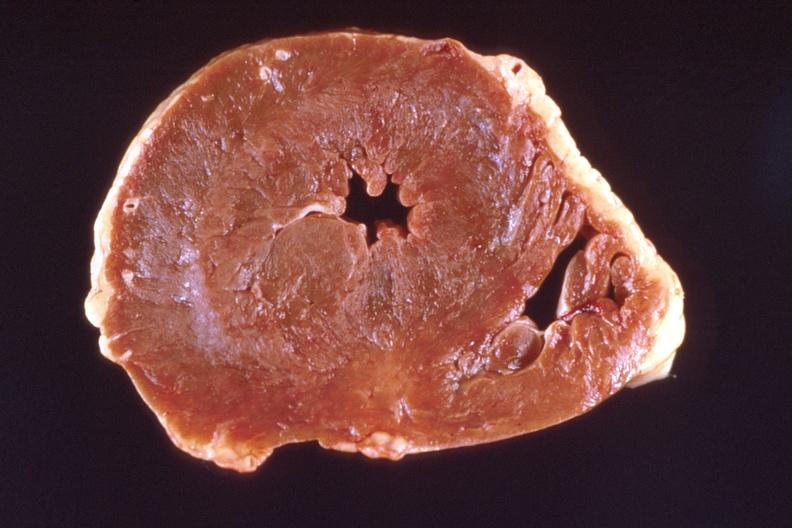where is this?
Answer the question using a single word or phrase. Heart 